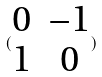Convert formula to latex. <formula><loc_0><loc_0><loc_500><loc_500>( \begin{matrix} 0 & - 1 \\ 1 & 0 \end{matrix} )</formula> 